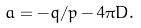Convert formula to latex. <formula><loc_0><loc_0><loc_500><loc_500>a = - q / p - 4 \pi D .</formula> 